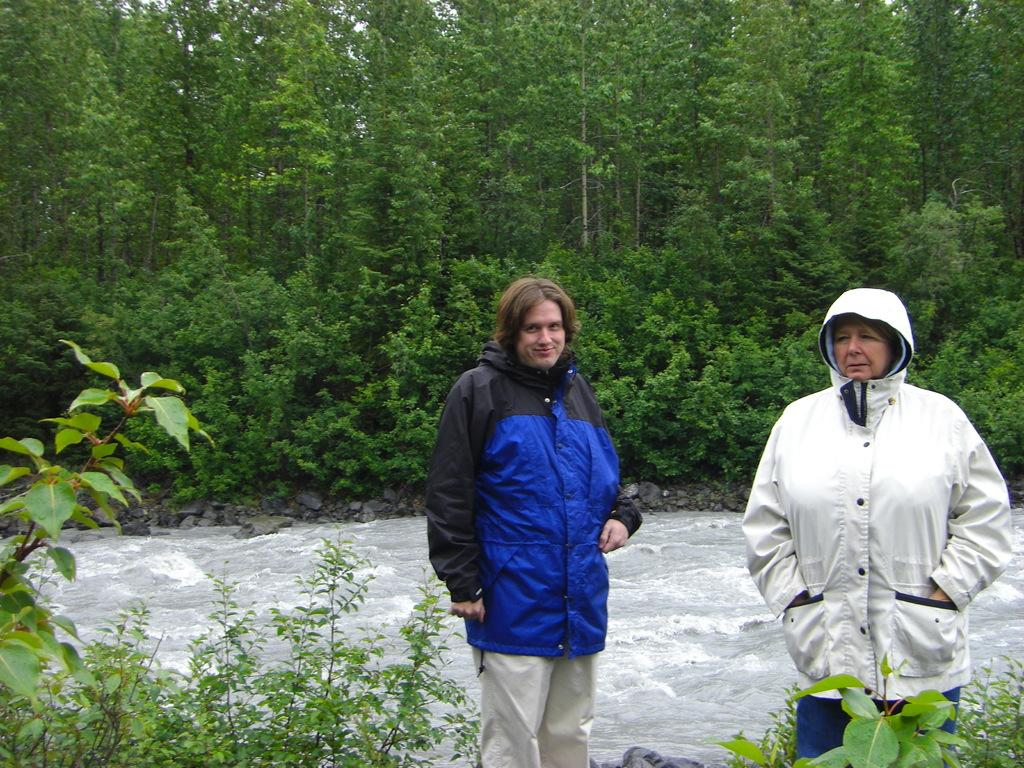How many people are present in the image? There are two people standing in the image. What is happening in the image involving water? There is a water flow in the image. What type of vegetation can be seen in the background of the image? There are plants and trees in the background of the image. Where is the rabbit hiding in the image? There is no rabbit present in the image. What type of cakes are being served in the image? There is no mention of cakes in the image. 